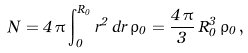<formula> <loc_0><loc_0><loc_500><loc_500>N = 4 \, \pi \int ^ { R _ { 0 } } _ { 0 } { r ^ { 2 } \, d r \, \rho _ { 0 } } = \frac { 4 \, \pi } { 3 } \, R ^ { 3 } _ { 0 } \, \rho _ { 0 } \, ,</formula> 